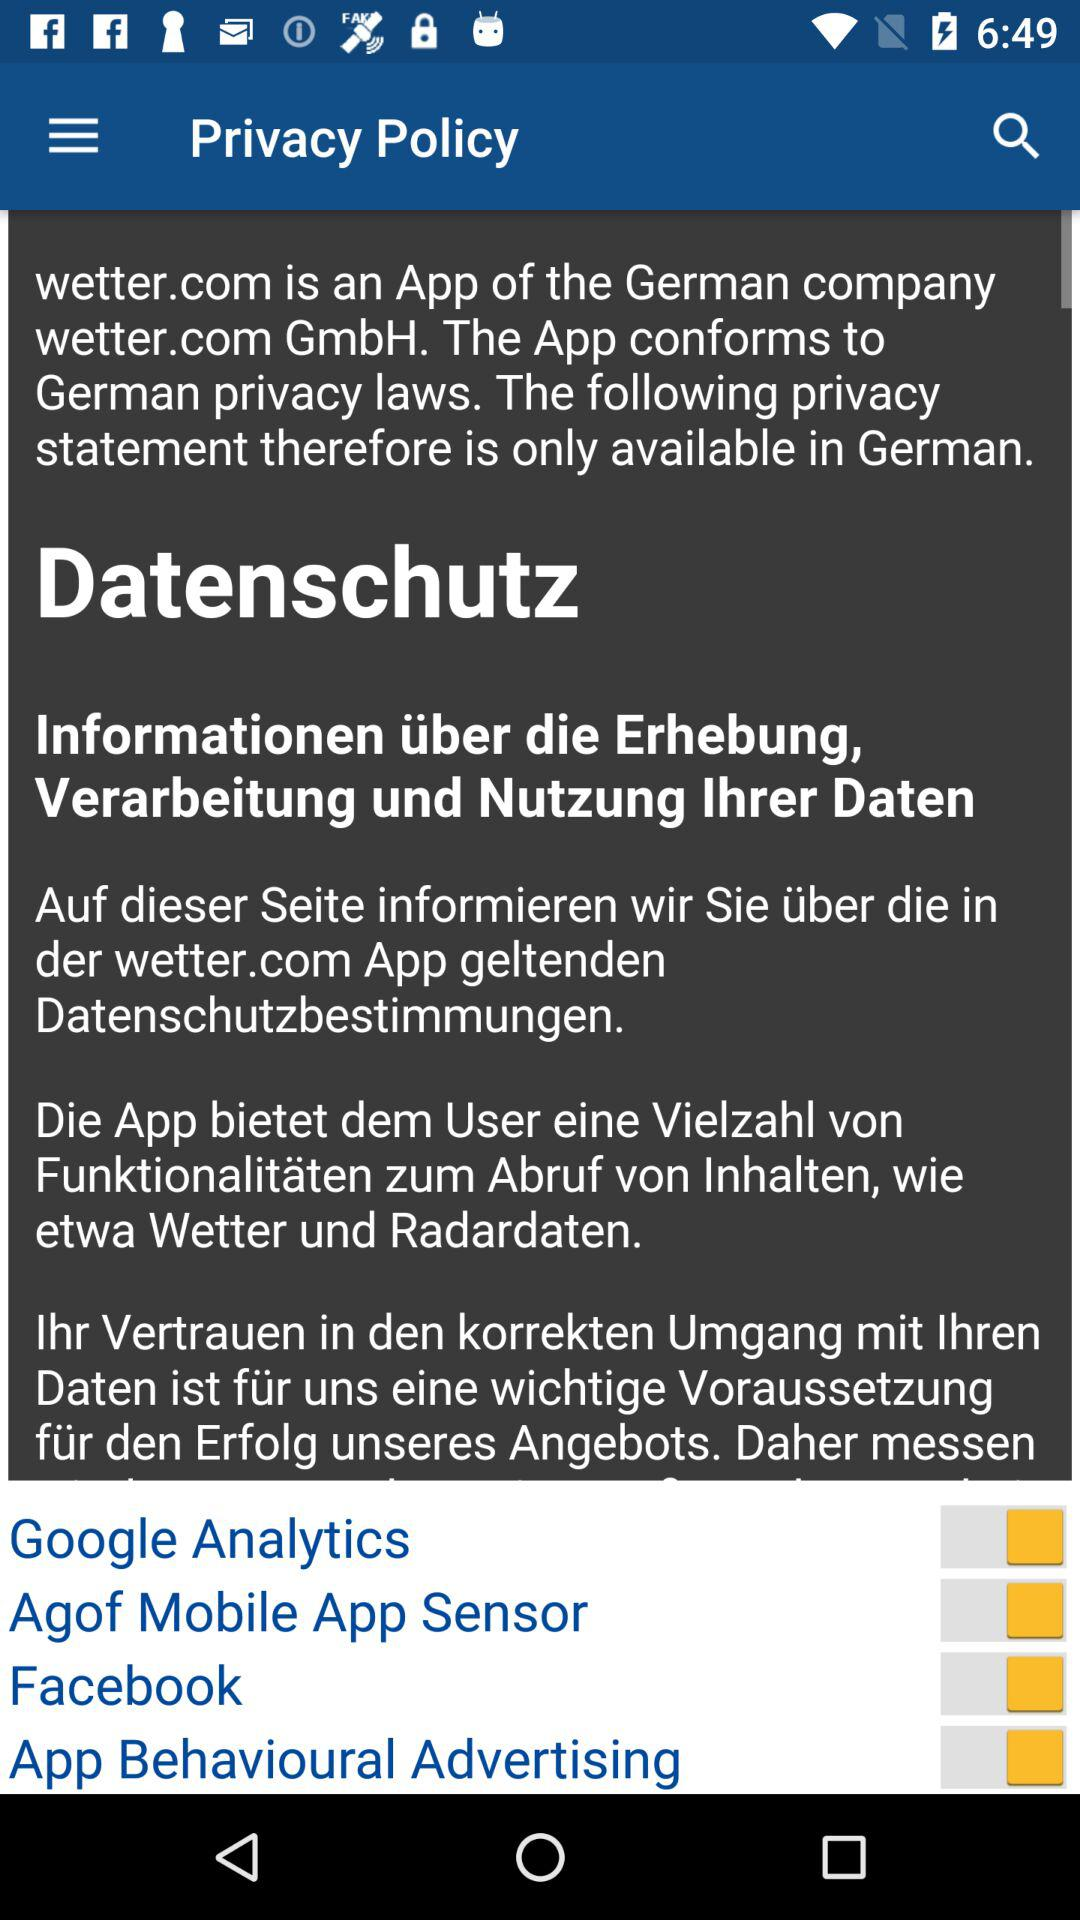What is the status of the Facebook? The status is on. 